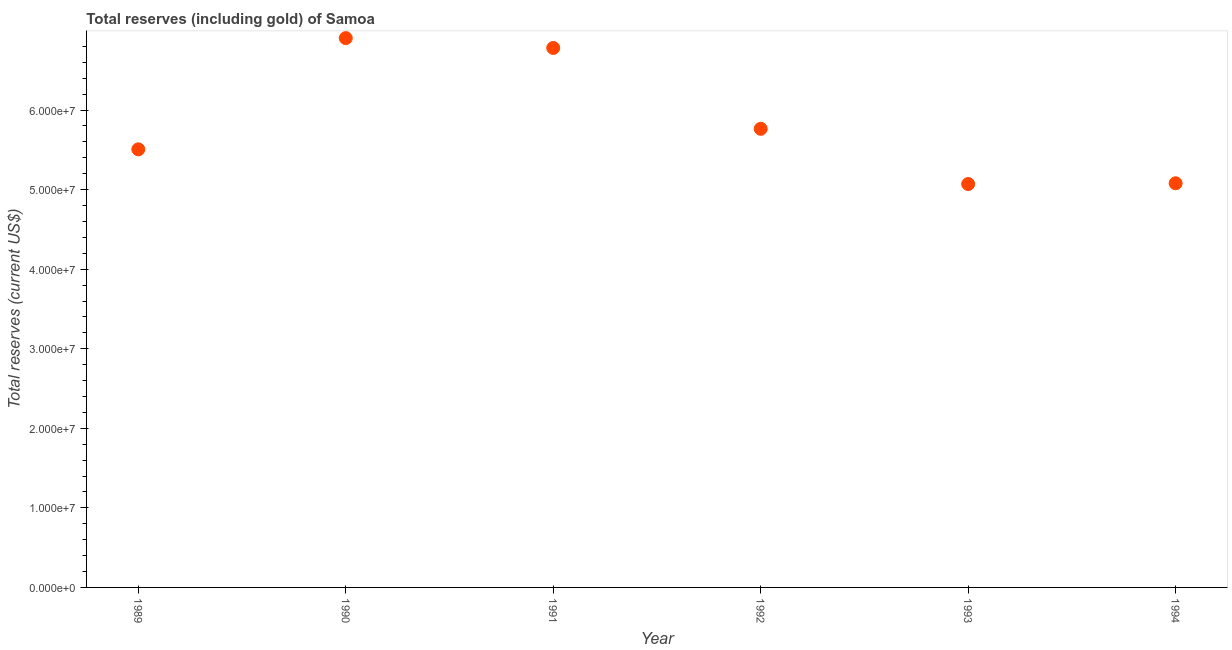What is the total reserves (including gold) in 1993?
Offer a very short reply. 5.07e+07. Across all years, what is the maximum total reserves (including gold)?
Provide a short and direct response. 6.90e+07. Across all years, what is the minimum total reserves (including gold)?
Give a very brief answer. 5.07e+07. In which year was the total reserves (including gold) maximum?
Give a very brief answer. 1990. What is the sum of the total reserves (including gold)?
Provide a short and direct response. 3.51e+08. What is the difference between the total reserves (including gold) in 1990 and 1994?
Your response must be concise. 1.82e+07. What is the average total reserves (including gold) per year?
Make the answer very short. 5.85e+07. What is the median total reserves (including gold)?
Your answer should be compact. 5.64e+07. What is the ratio of the total reserves (including gold) in 1992 to that in 1993?
Your answer should be compact. 1.14. Is the total reserves (including gold) in 1992 less than that in 1994?
Your response must be concise. No. What is the difference between the highest and the second highest total reserves (including gold)?
Your answer should be very brief. 1.24e+06. Is the sum of the total reserves (including gold) in 1989 and 1993 greater than the maximum total reserves (including gold) across all years?
Offer a terse response. Yes. What is the difference between the highest and the lowest total reserves (including gold)?
Give a very brief answer. 1.83e+07. How many dotlines are there?
Provide a succinct answer. 1. How many years are there in the graph?
Offer a very short reply. 6. Does the graph contain any zero values?
Give a very brief answer. No. Does the graph contain grids?
Provide a short and direct response. No. What is the title of the graph?
Keep it short and to the point. Total reserves (including gold) of Samoa. What is the label or title of the X-axis?
Ensure brevity in your answer.  Year. What is the label or title of the Y-axis?
Ensure brevity in your answer.  Total reserves (current US$). What is the Total reserves (current US$) in 1989?
Your answer should be compact. 5.51e+07. What is the Total reserves (current US$) in 1990?
Keep it short and to the point. 6.90e+07. What is the Total reserves (current US$) in 1991?
Your answer should be compact. 6.78e+07. What is the Total reserves (current US$) in 1992?
Your answer should be very brief. 5.76e+07. What is the Total reserves (current US$) in 1993?
Your answer should be compact. 5.07e+07. What is the Total reserves (current US$) in 1994?
Your answer should be very brief. 5.08e+07. What is the difference between the Total reserves (current US$) in 1989 and 1990?
Ensure brevity in your answer.  -1.40e+07. What is the difference between the Total reserves (current US$) in 1989 and 1991?
Keep it short and to the point. -1.27e+07. What is the difference between the Total reserves (current US$) in 1989 and 1992?
Make the answer very short. -2.58e+06. What is the difference between the Total reserves (current US$) in 1989 and 1993?
Offer a terse response. 4.36e+06. What is the difference between the Total reserves (current US$) in 1989 and 1994?
Ensure brevity in your answer.  4.27e+06. What is the difference between the Total reserves (current US$) in 1990 and 1991?
Your answer should be very brief. 1.24e+06. What is the difference between the Total reserves (current US$) in 1990 and 1992?
Ensure brevity in your answer.  1.14e+07. What is the difference between the Total reserves (current US$) in 1990 and 1993?
Provide a short and direct response. 1.83e+07. What is the difference between the Total reserves (current US$) in 1990 and 1994?
Your answer should be compact. 1.82e+07. What is the difference between the Total reserves (current US$) in 1991 and 1992?
Offer a terse response. 1.02e+07. What is the difference between the Total reserves (current US$) in 1991 and 1993?
Give a very brief answer. 1.71e+07. What is the difference between the Total reserves (current US$) in 1991 and 1994?
Your answer should be compact. 1.70e+07. What is the difference between the Total reserves (current US$) in 1992 and 1993?
Offer a terse response. 6.94e+06. What is the difference between the Total reserves (current US$) in 1992 and 1994?
Make the answer very short. 6.85e+06. What is the difference between the Total reserves (current US$) in 1993 and 1994?
Offer a terse response. -9.47e+04. What is the ratio of the Total reserves (current US$) in 1989 to that in 1990?
Provide a short and direct response. 0.8. What is the ratio of the Total reserves (current US$) in 1989 to that in 1991?
Give a very brief answer. 0.81. What is the ratio of the Total reserves (current US$) in 1989 to that in 1992?
Ensure brevity in your answer.  0.95. What is the ratio of the Total reserves (current US$) in 1989 to that in 1993?
Offer a terse response. 1.09. What is the ratio of the Total reserves (current US$) in 1989 to that in 1994?
Keep it short and to the point. 1.08. What is the ratio of the Total reserves (current US$) in 1990 to that in 1992?
Ensure brevity in your answer.  1.2. What is the ratio of the Total reserves (current US$) in 1990 to that in 1993?
Keep it short and to the point. 1.36. What is the ratio of the Total reserves (current US$) in 1990 to that in 1994?
Your answer should be compact. 1.36. What is the ratio of the Total reserves (current US$) in 1991 to that in 1992?
Provide a short and direct response. 1.18. What is the ratio of the Total reserves (current US$) in 1991 to that in 1993?
Offer a terse response. 1.34. What is the ratio of the Total reserves (current US$) in 1991 to that in 1994?
Your response must be concise. 1.33. What is the ratio of the Total reserves (current US$) in 1992 to that in 1993?
Ensure brevity in your answer.  1.14. What is the ratio of the Total reserves (current US$) in 1992 to that in 1994?
Offer a very short reply. 1.14. What is the ratio of the Total reserves (current US$) in 1993 to that in 1994?
Provide a short and direct response. 1. 